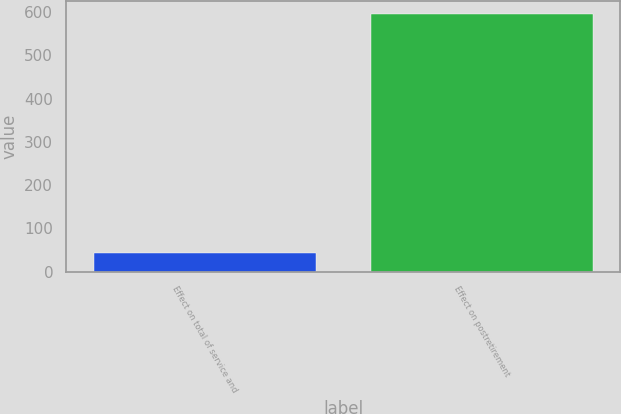Convert chart. <chart><loc_0><loc_0><loc_500><loc_500><bar_chart><fcel>Effect on total of service and<fcel>Effect on postretirement<nl><fcel>43<fcel>596<nl></chart> 